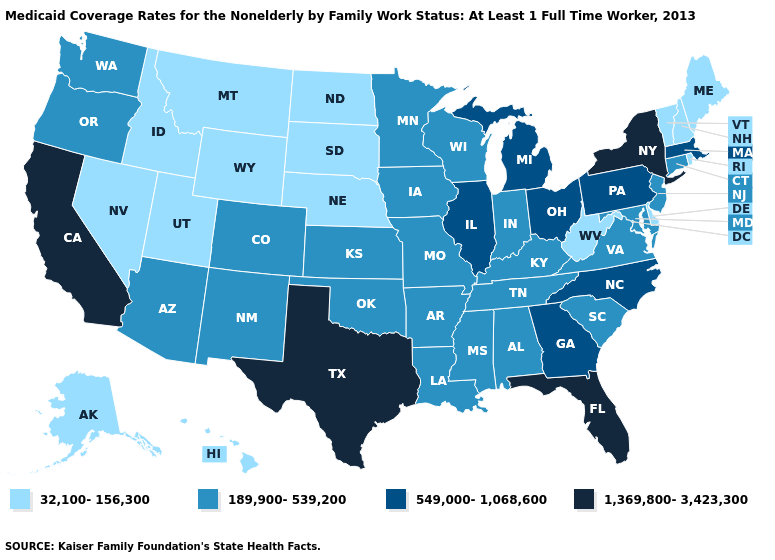What is the value of Wisconsin?
Answer briefly. 189,900-539,200. What is the value of Wyoming?
Give a very brief answer. 32,100-156,300. What is the highest value in states that border New York?
Keep it brief. 549,000-1,068,600. What is the highest value in the MidWest ?
Keep it brief. 549,000-1,068,600. Does Florida have the highest value in the South?
Concise answer only. Yes. Does the map have missing data?
Be succinct. No. What is the lowest value in states that border Massachusetts?
Keep it brief. 32,100-156,300. Does Illinois have the highest value in the USA?
Write a very short answer. No. What is the lowest value in states that border Iowa?
Concise answer only. 32,100-156,300. What is the highest value in the USA?
Quick response, please. 1,369,800-3,423,300. Does the first symbol in the legend represent the smallest category?
Concise answer only. Yes. Among the states that border New Jersey , which have the highest value?
Write a very short answer. New York. Does the map have missing data?
Quick response, please. No. What is the highest value in the Northeast ?
Concise answer only. 1,369,800-3,423,300. What is the highest value in the USA?
Concise answer only. 1,369,800-3,423,300. 